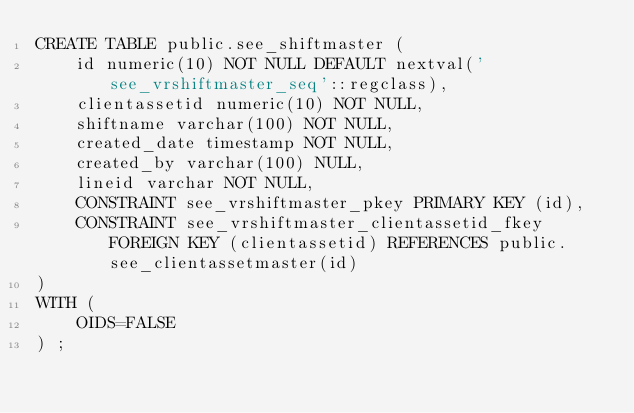Convert code to text. <code><loc_0><loc_0><loc_500><loc_500><_SQL_>CREATE TABLE public.see_shiftmaster (
	id numeric(10) NOT NULL DEFAULT nextval('see_vrshiftmaster_seq'::regclass),
	clientassetid numeric(10) NOT NULL,
	shiftname varchar(100) NOT NULL,
	created_date timestamp NOT NULL,
	created_by varchar(100) NULL,
	lineid varchar NOT NULL,
	CONSTRAINT see_vrshiftmaster_pkey PRIMARY KEY (id),
	CONSTRAINT see_vrshiftmaster_clientassetid_fkey FOREIGN KEY (clientassetid) REFERENCES public.see_clientassetmaster(id)
)
WITH (
	OIDS=FALSE
) ;
</code> 